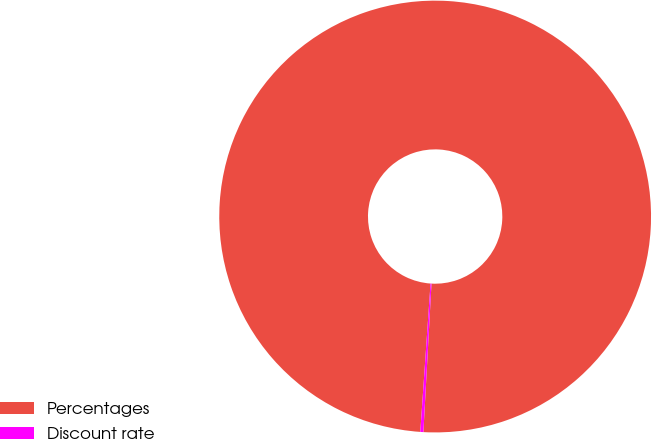Convert chart. <chart><loc_0><loc_0><loc_500><loc_500><pie_chart><fcel>Percentages<fcel>Discount rate<nl><fcel>99.77%<fcel>0.23%<nl></chart> 